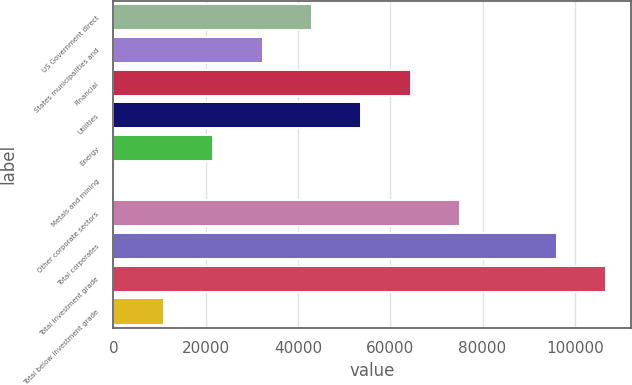Convert chart to OTSL. <chart><loc_0><loc_0><loc_500><loc_500><bar_chart><fcel>US Government direct<fcel>States municipalities and<fcel>Financial<fcel>Utilities<fcel>Energy<fcel>Metals and mining<fcel>Other corporate sectors<fcel>Total corporates<fcel>Total investment grade<fcel>Total below investment grade<nl><fcel>43043.4<fcel>32340.3<fcel>64449.6<fcel>53746.5<fcel>21637.2<fcel>231<fcel>75152.7<fcel>96104<fcel>106807<fcel>10934.1<nl></chart> 